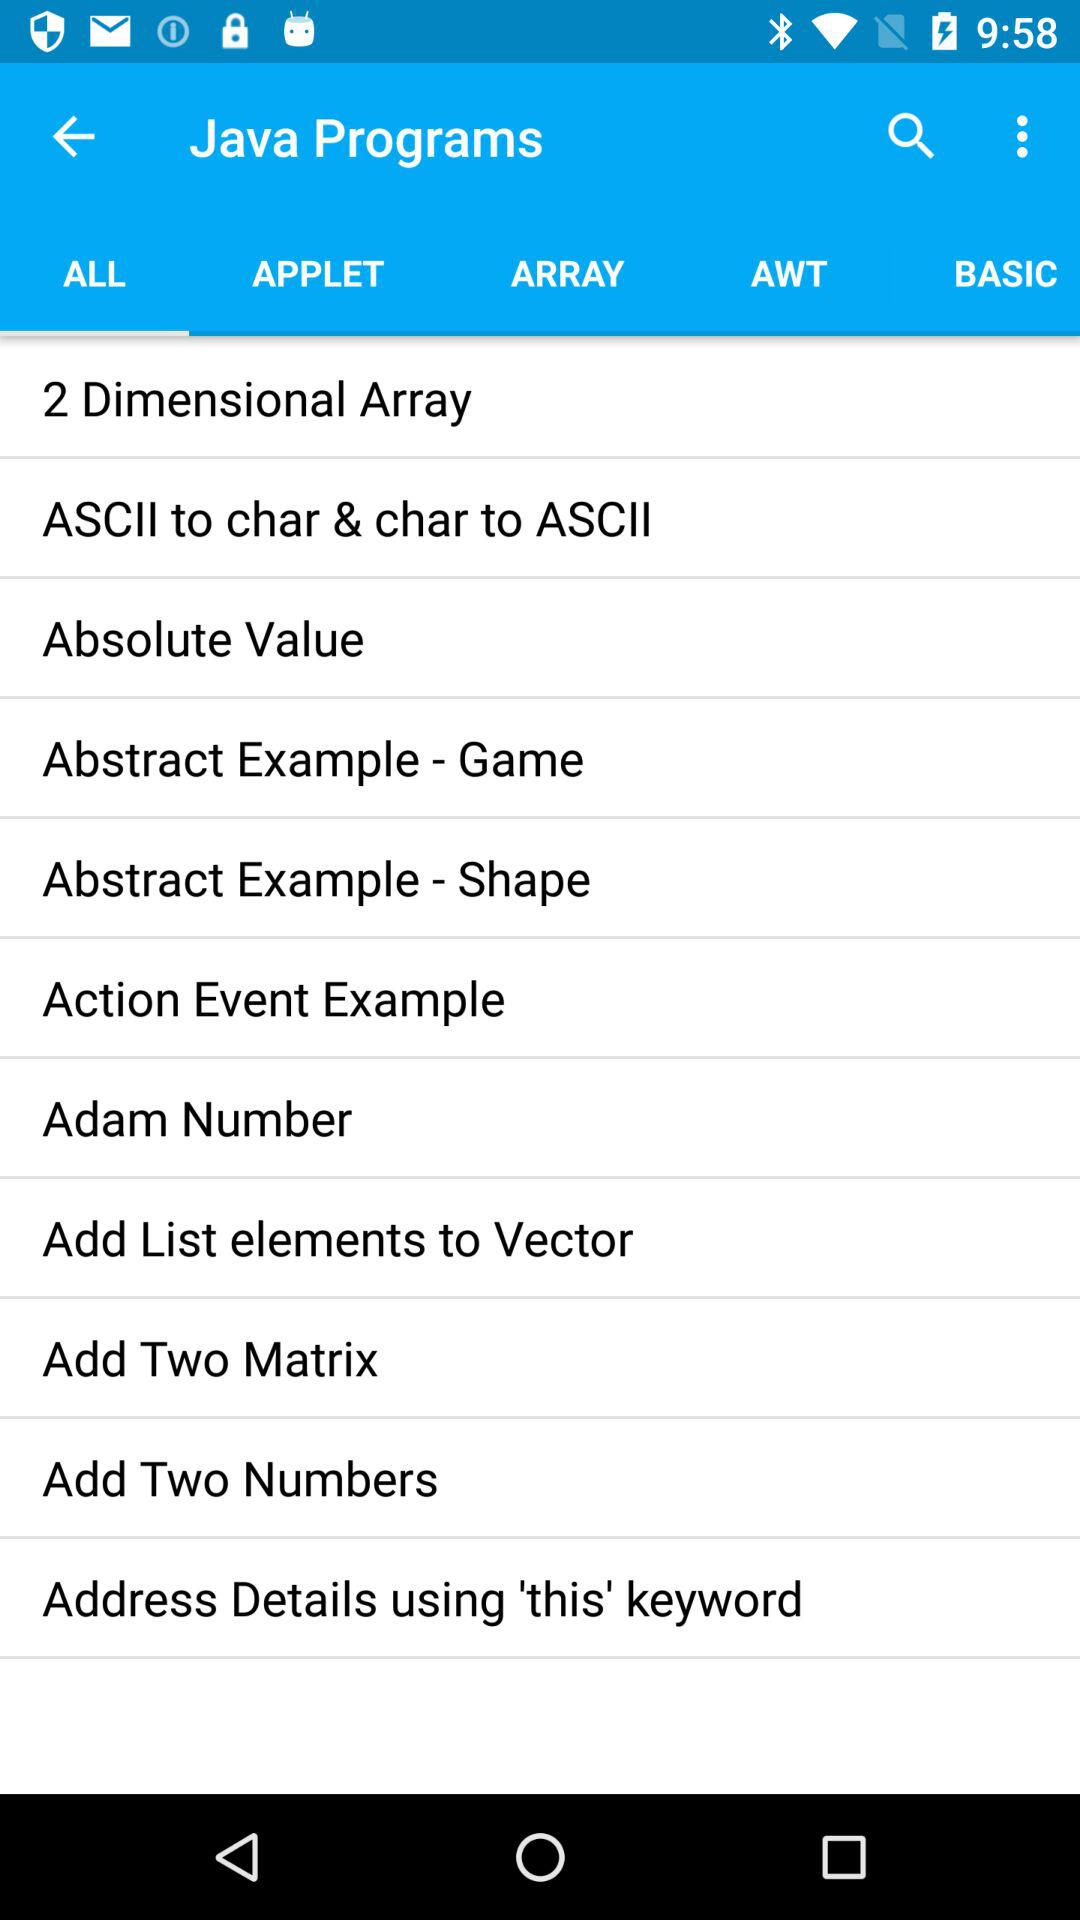When was "Java Programs" updated?
When the provided information is insufficient, respond with <no answer>. <no answer> 